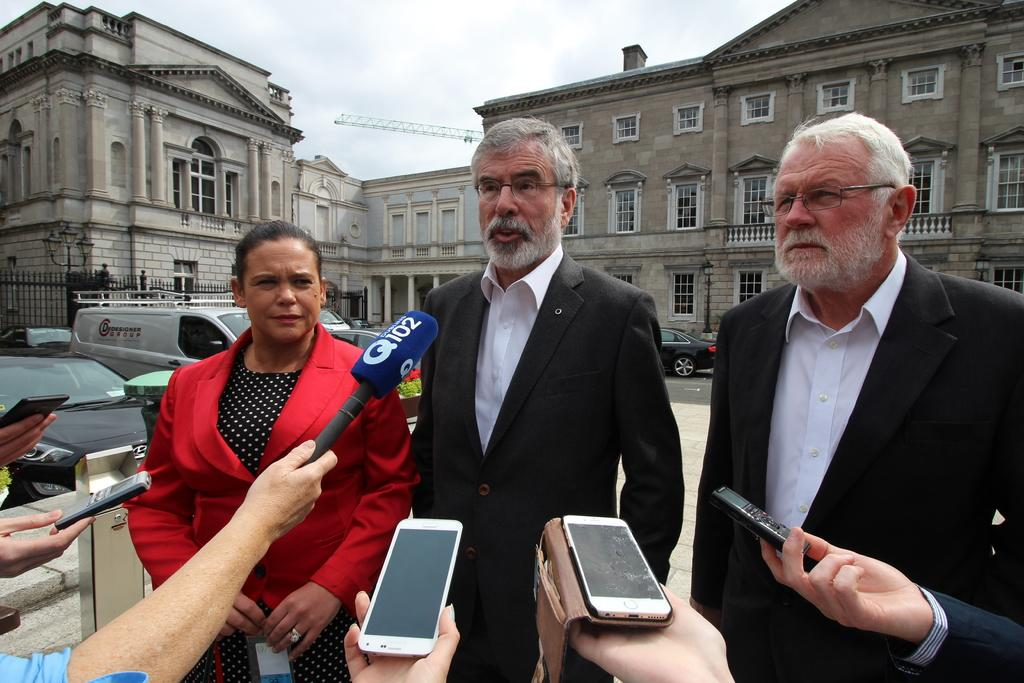Provide a one-sentence caption for the provided image. someone from Q102, along with others listening and recording gentleman and two others. 